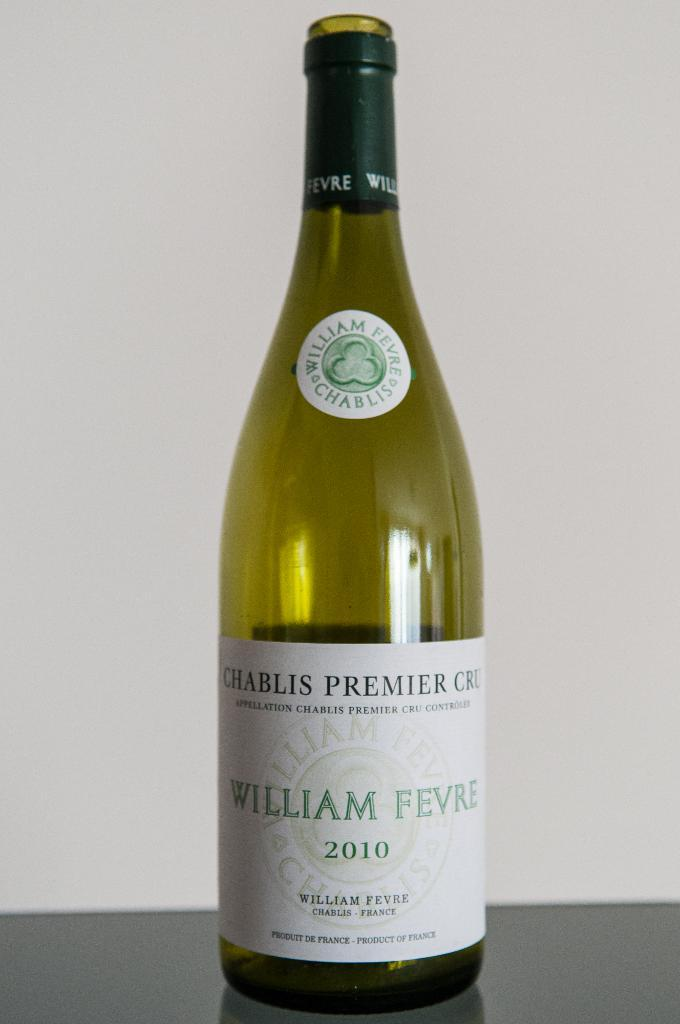<image>
Render a clear and concise summary of the photo. A bottle of William Fevre is empty on a counter 